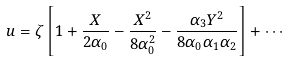<formula> <loc_0><loc_0><loc_500><loc_500>u = \zeta \left [ 1 + \frac { X } { 2 \alpha _ { 0 } } - \frac { X ^ { 2 } } { 8 \alpha _ { 0 } ^ { 2 } } - \frac { \alpha _ { 3 } Y ^ { 2 } } { 8 \alpha _ { 0 } \alpha _ { 1 } \alpha _ { 2 } } \right ] + \cdots</formula> 